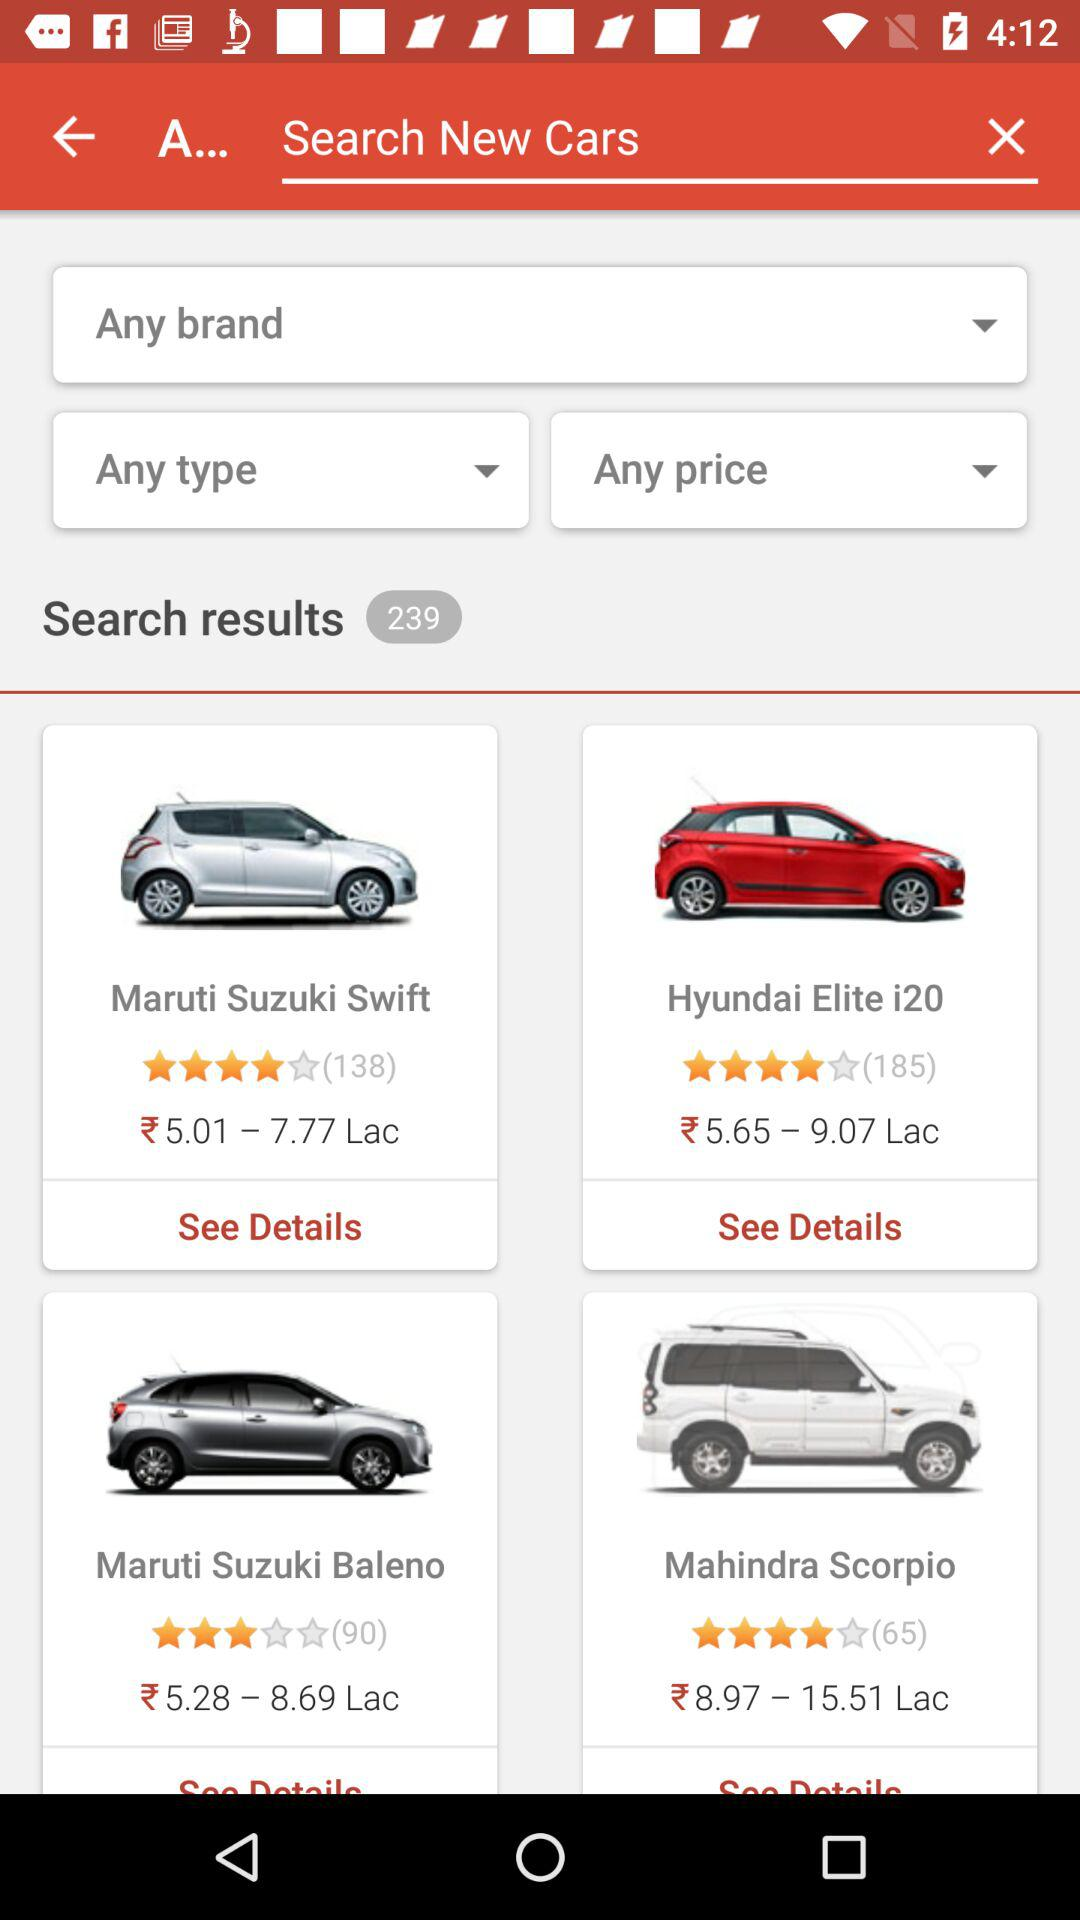What is the price range of the Maruti Suzuki Swift? The price range of the Maruti Suzuki Swift is ₹ 5.01 to 7.77 Lac. 